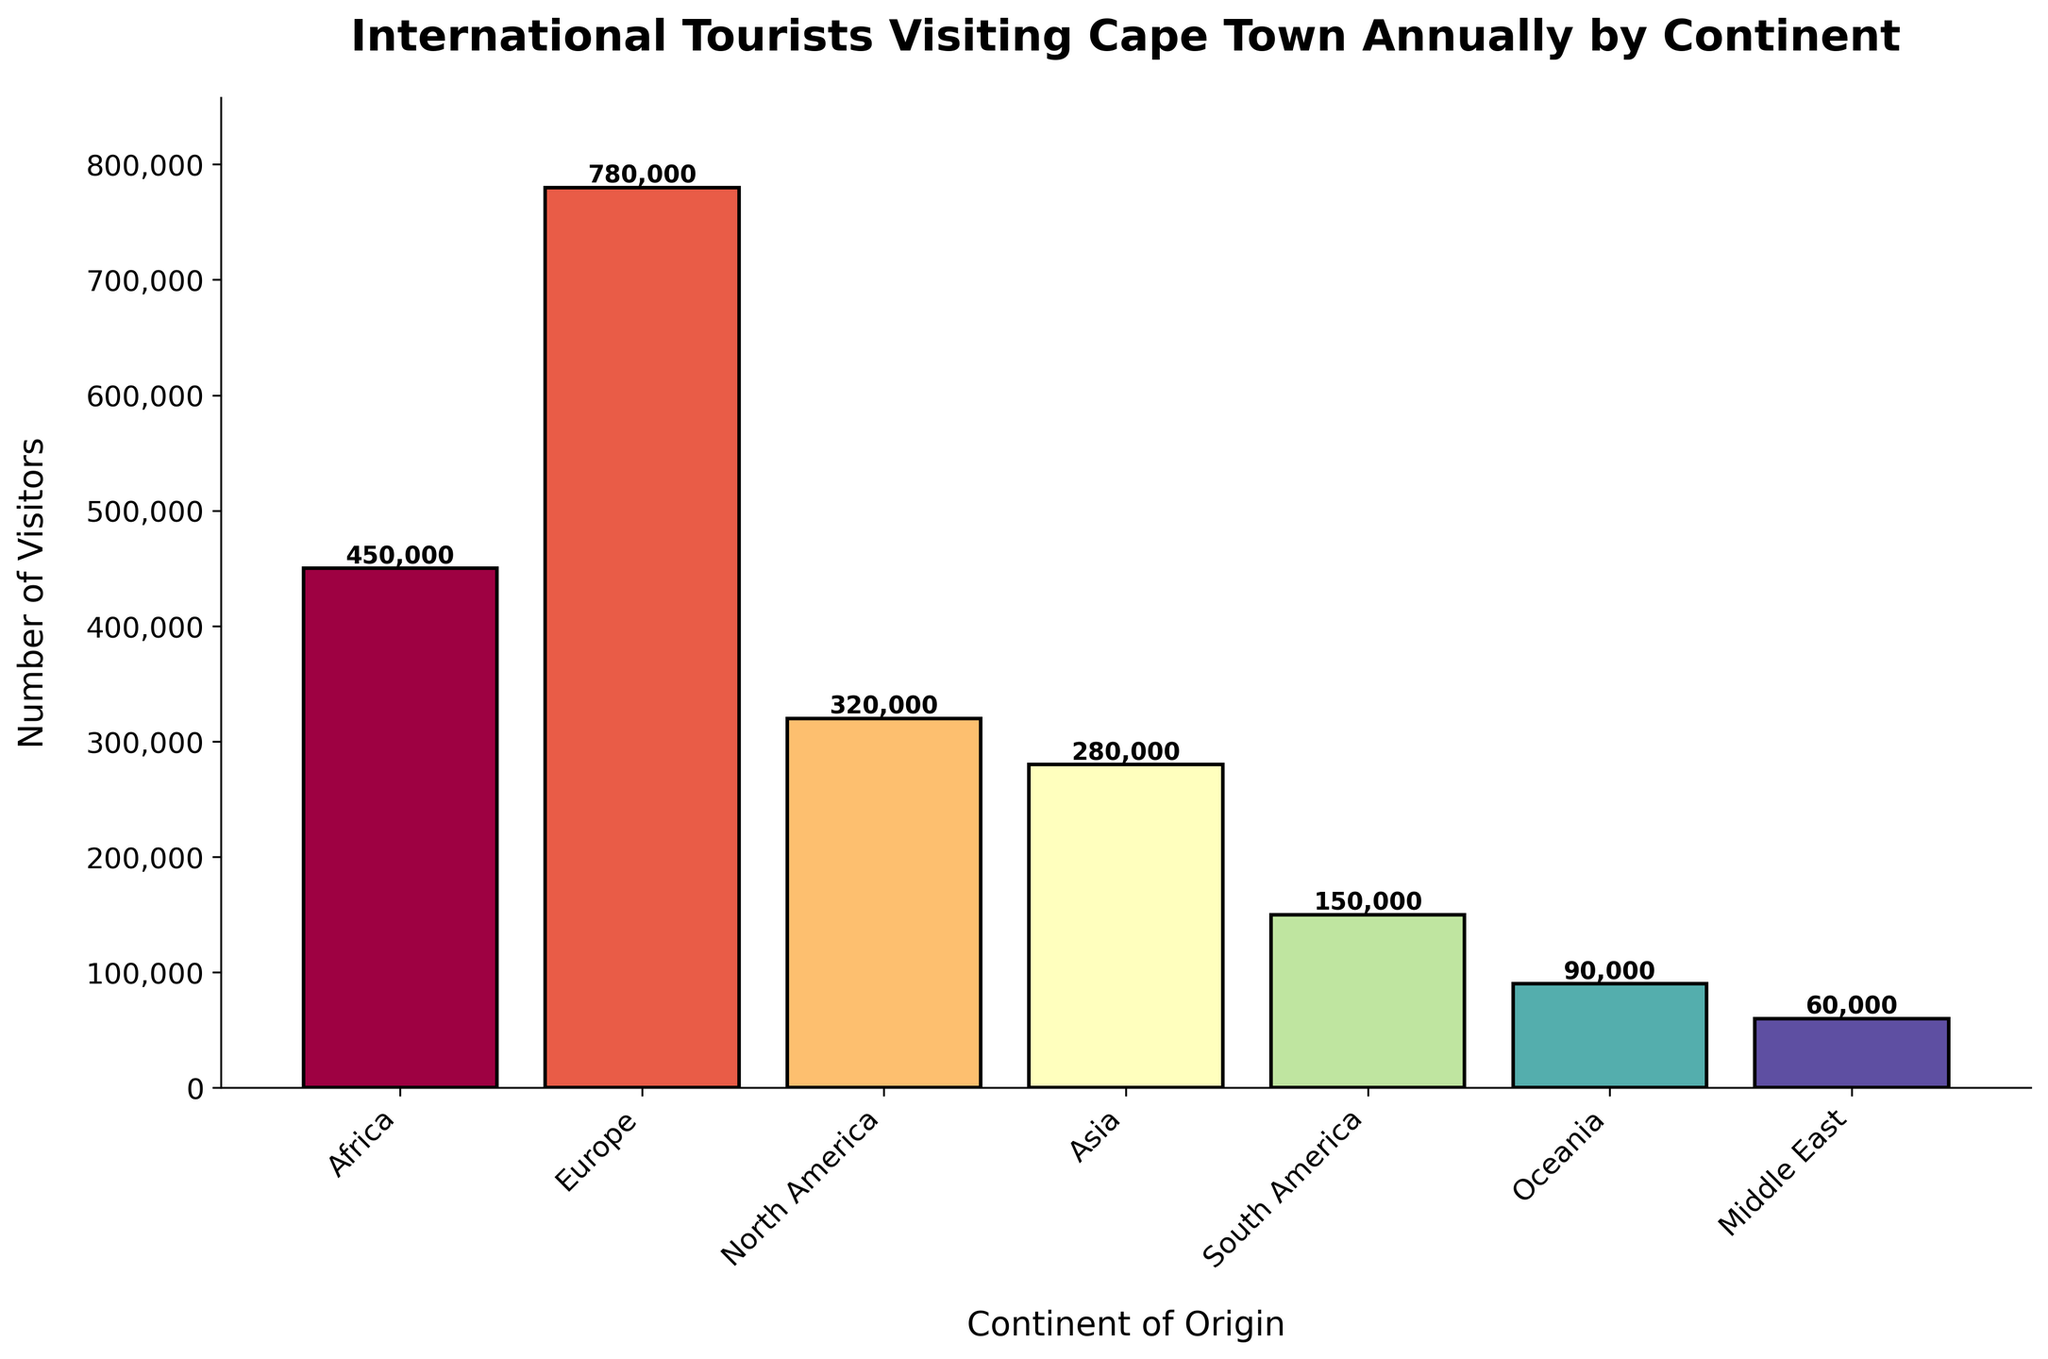Which continent has the highest number of visitors? By observing the height of the bars, Europe has the tallest bar, indicating the highest number of visitors.
Answer: Europe What is the total number of visitors from all continents combined? Sum the number of visitors from each continent: 450,000 (Africa) + 780,000 (Europe) + 320,000 (North America) + 280,000 (Asia) + 150,000 (South America) + 90,000 (Oceania) + 60,000 (Middle East) = 2,130,000.
Answer: 2,130,000 How many more visitors does Europe have compared to North America? Subtract the number of visitors from North America from Europe: 780,000 (Europe) - 320,000 (North America) = 460,000.
Answer: 460,000 Which continent has the fewest visitors? The Middle East has the shortest bar, indicating the fewest number of visitors.
Answer: Middle East Is the number of visitors from Asia higher or lower than the number of visitors from North America? By comparing the heights of the bars, North America has a taller bar than Asia, indicating more visitors.
Answer: Lower How much higher is the number of visitors from Europe compared to Asia and South America combined? First, sum the number of visitors from Asia and South America: 280,000 (Asia) + 150,000 (South America) = 430,000. Then, subtract this sum from the number of visitors from Europe: 780,000 (Europe) - 430,000 = 350,000.
Answer: 350,000 Which continents have more than 300,000 visitors? By observing the heights of the bars, continents with more than 300,000 visitors are Africa, Europe, and North America.
Answer: Africa, Europe, North America What is the combined number of visitors from Oceania and the Middle East? Sum the number of visitors from Oceania and the Middle East: 90,000 (Oceania) + 60,000 (Middle East) = 150,000.
Answer: 150,000 What is the difference in the number of visitors between Africa and Asia? Subtract the number of visitors from Asia from Africa: 450,000 (Africa) - 280,000 (Asia) = 170,000.
Answer: 170,000 What is the average number of visitors per continent? First, find the total number of visitors: 2,130,000. Then, divide this by the number of continents (7): 2,130,000 / 7 ≈ 304,286.
Answer: 304,286 